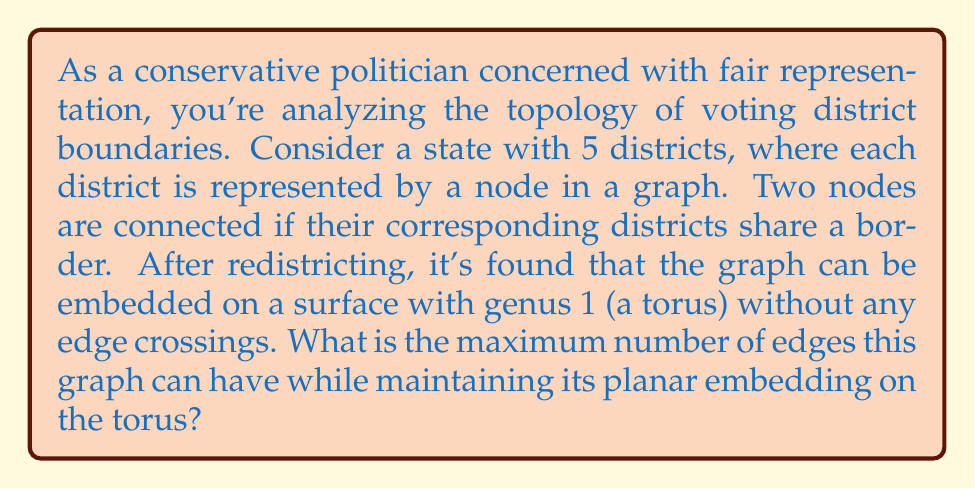Help me with this question. To solve this problem, we need to apply the Euler characteristic formula for graphs on a torus and maximize the number of edges. Let's approach this step-by-step:

1. Recall the Euler characteristic formula for a graph embedded on a surface with genus $g$:

   $$V - E + F = 2 - 2g$$

   where $V$ is the number of vertices, $E$ is the number of edges, and $F$ is the number of faces.

2. In this case, we have:
   - $V = 5$ (5 districts)
   - $g = 1$ (the graph is embedded on a torus)

3. Substituting these values into the formula:

   $$5 - E + F = 2 - 2(1) = 0$$

4. Rearranging the equation:

   $$F = E - 5$$

5. Now, we need to consider the relationship between faces and edges in a graph. Each face in a simple graph must be bounded by at least 3 edges. Therefore:

   $$3F \leq 2E$$

6. Substituting the expression for $F$ from step 4:

   $$3(E - 5) \leq 2E$$

7. Solving this inequality:

   $$3E - 15 \leq 2E$$
   $$E \leq 15$$

8. Therefore, the maximum number of edges in this graph is 15.

This result aligns with the concept of a complete graph on 5 vertices ($K_5$), which has $\frac{5(5-1)}{2} = 10$ edges when embedded in a plane, but can have up to 15 edges when embedded on a torus without crossings.
Answer: The maximum number of edges in the graph is 15. 